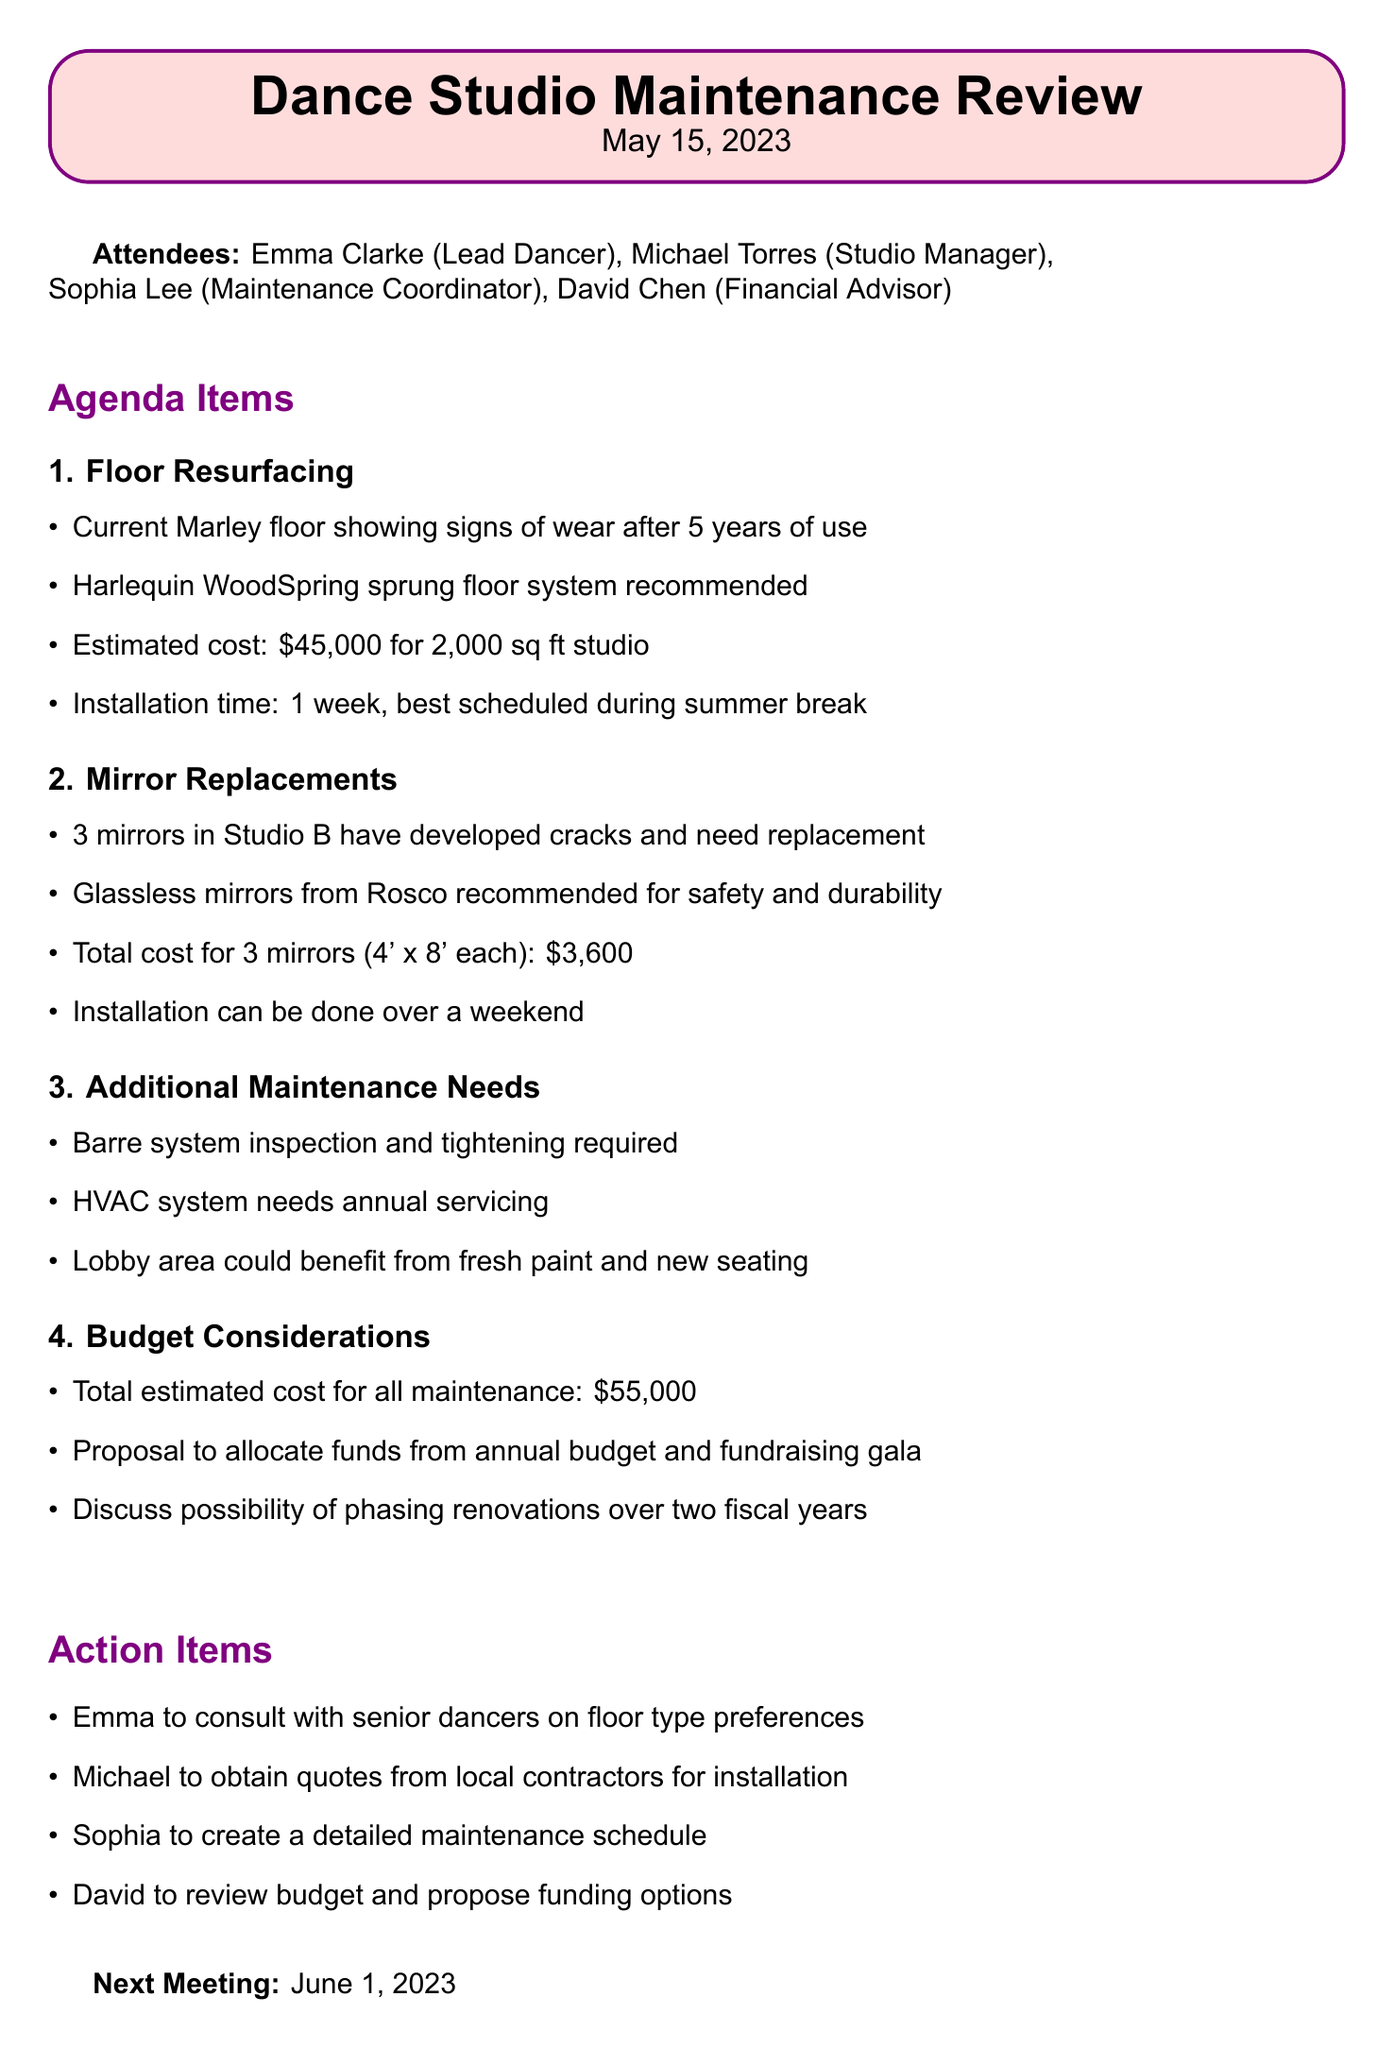What is the date of the meeting? The date of the meeting is explicitly stated in the document as May 15, 2023.
Answer: May 15, 2023 Who is the Lead Dancer? The Lead Dancer is mentioned in the attendees list as Emma Clarke.
Answer: Emma Clarke What is the estimated installation time for the new floor? The estimated installation time for the new floor is specified in the agenda as 1 week.
Answer: 1 week What total cost is estimated for mirror replacements? The document provides the total cost for mirror replacements as $3,600 for three mirrors.
Answer: $3,600 Which floor system is recommended for replacement? The recommended floor system is mentioned in the document as Harlequin WoodSpring sprung floor system.
Answer: Harlequin WoodSpring sprung floor system How many mirrors need replacement in Studio B? The document notes that 3 mirrors in Studio B have developed cracks and need replacement.
Answer: 3 mirrors What is the total estimated cost for all maintenance needs? The total estimated cost for all maintenance needs is clearly stated as $55,000.
Answer: $55,000 When is the next meeting scheduled? The next meeting date is specified in the document as June 1, 2023.
Answer: June 1, 2023 What item requires inspection and tightening? The document mentions the barre system requires inspection and tightening.
Answer: Barre system 